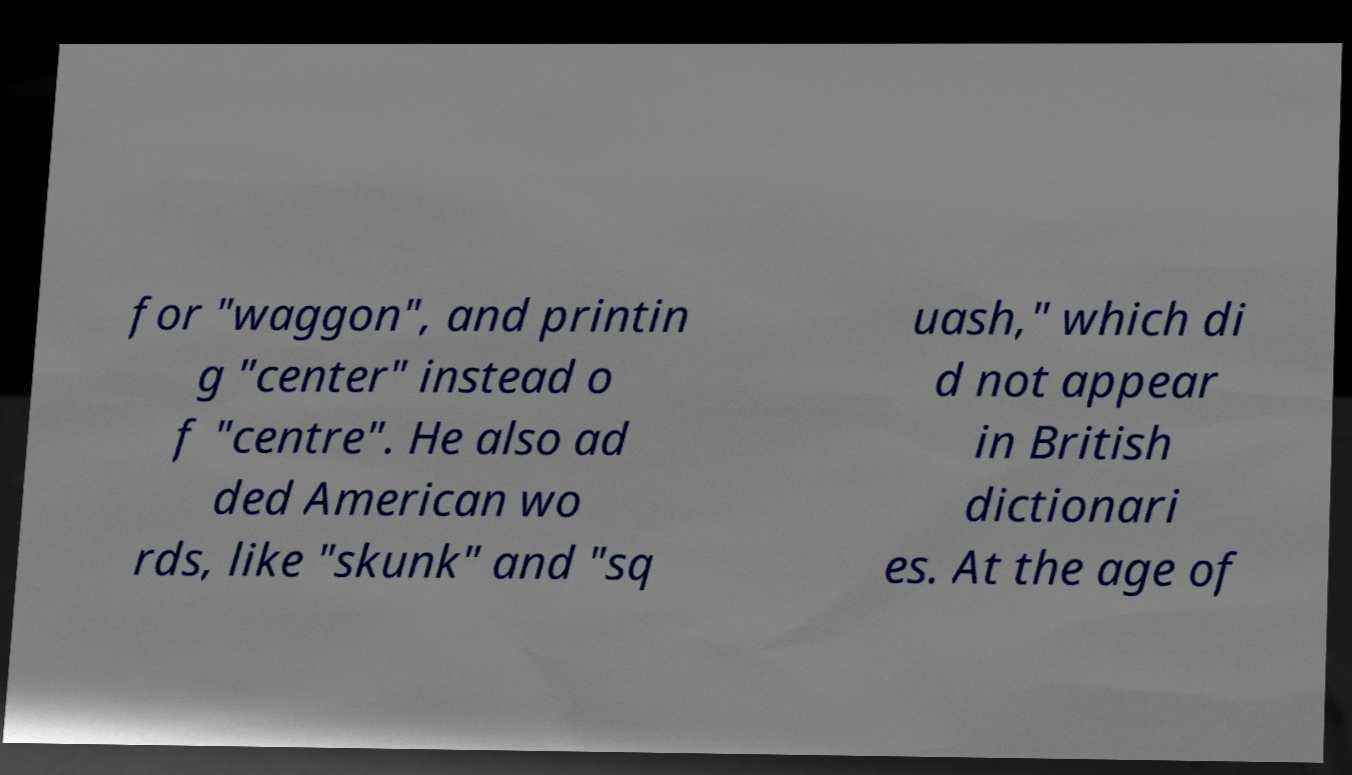There's text embedded in this image that I need extracted. Can you transcribe it verbatim? for "waggon", and printin g "center" instead o f "centre". He also ad ded American wo rds, like "skunk" and "sq uash," which di d not appear in British dictionari es. At the age of 